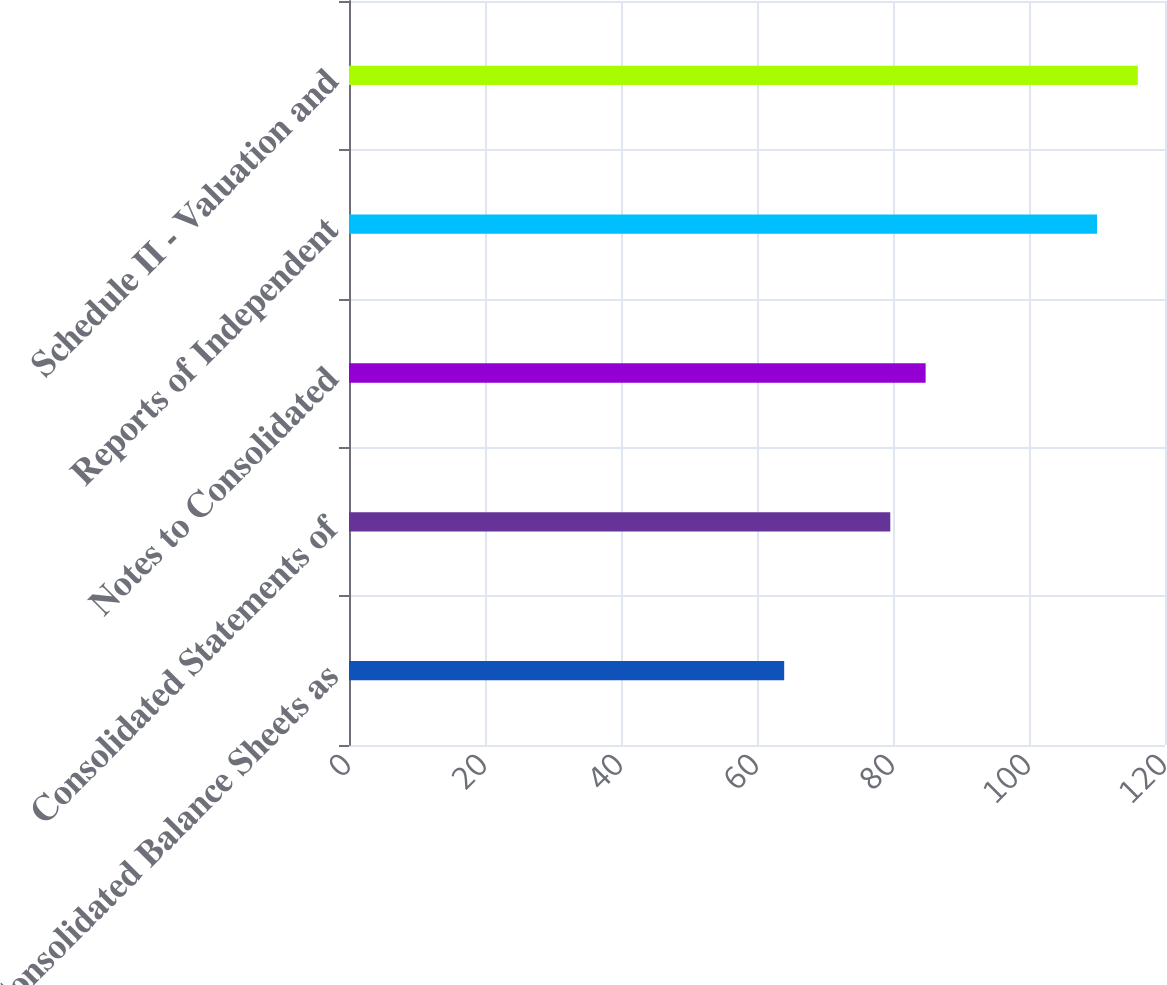<chart> <loc_0><loc_0><loc_500><loc_500><bar_chart><fcel>Consolidated Balance Sheets as<fcel>Consolidated Statements of<fcel>Notes to Consolidated<fcel>Reports of Independent<fcel>Schedule II - Valuation and<nl><fcel>64<fcel>79.6<fcel>84.8<fcel>110<fcel>116<nl></chart> 